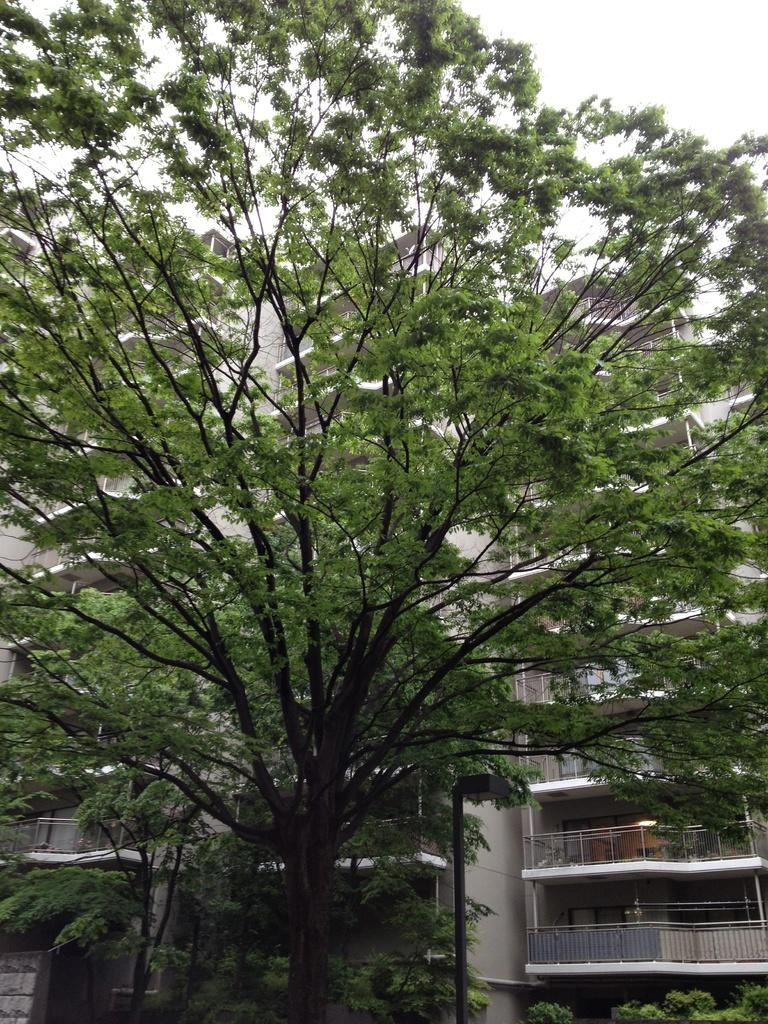What type of vegetation can be seen in the image? There are trees in the image. What structures are visible behind the trees? There are buildings visible behind the trees. What part of the natural environment is visible in the image? The sky is visible in the image. What type of boot is being attacked by the trees in the image? There is no boot present in the image, nor are the trees attacking anything. 